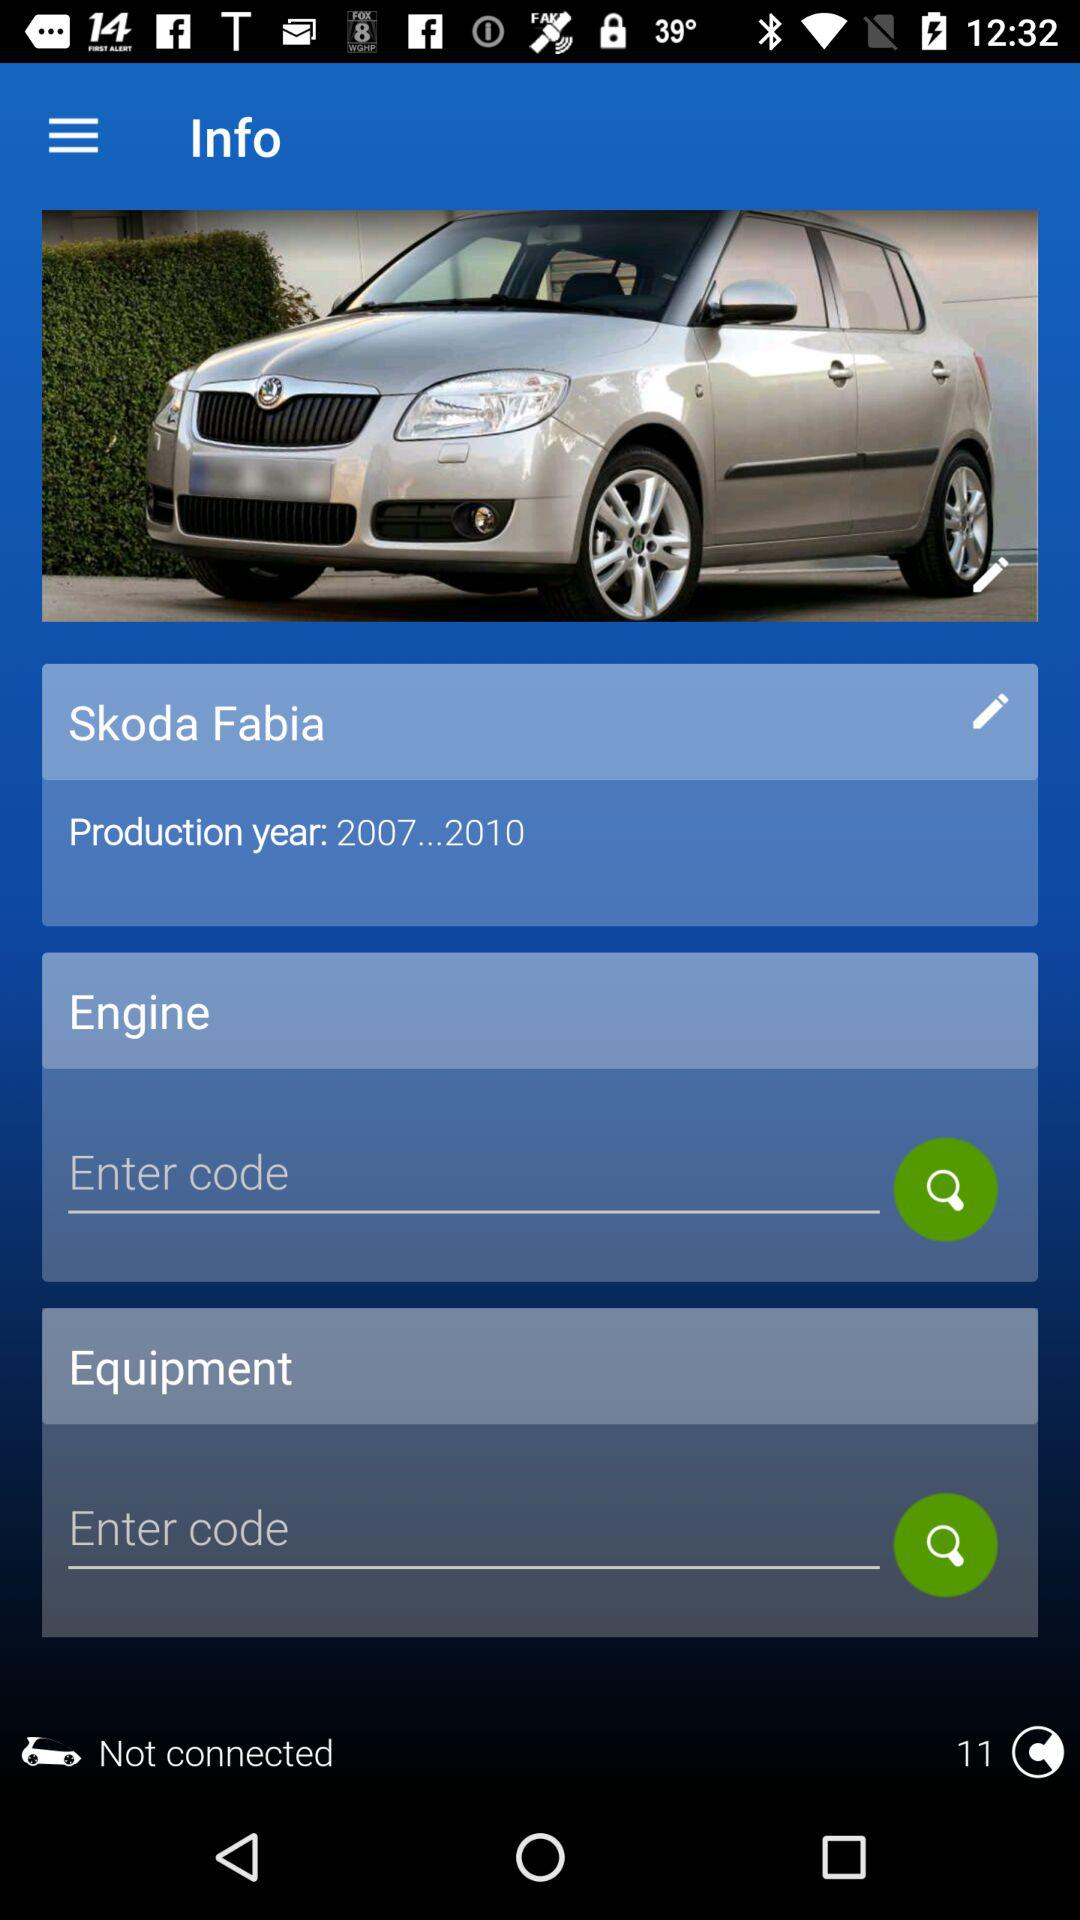What is the production year? The production year is from 2007 to 2010. 